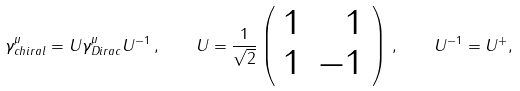Convert formula to latex. <formula><loc_0><loc_0><loc_500><loc_500>\gamma ^ { \mu } _ { c h i r a l } = U \gamma ^ { \mu } _ { D i r a c } U ^ { - 1 } \, , \quad U = \frac { 1 } { \sqrt { 2 } } \left ( \begin{array} { r r } 1 & 1 \\ 1 & - 1 \end{array} \right ) \, , \quad U ^ { - 1 } = U ^ { + } ,</formula> 